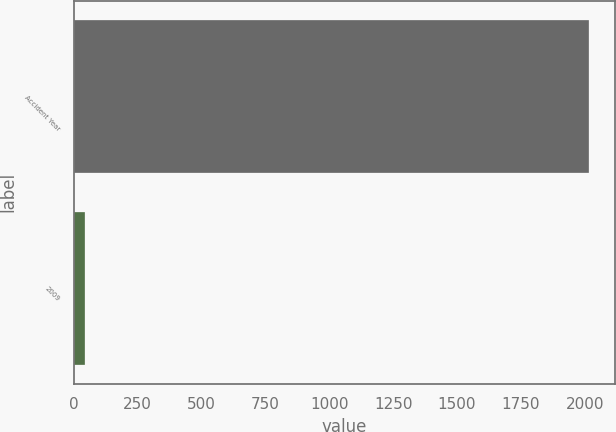Convert chart to OTSL. <chart><loc_0><loc_0><loc_500><loc_500><bar_chart><fcel>Accident Year<fcel>2009<nl><fcel>2018<fcel>43<nl></chart> 